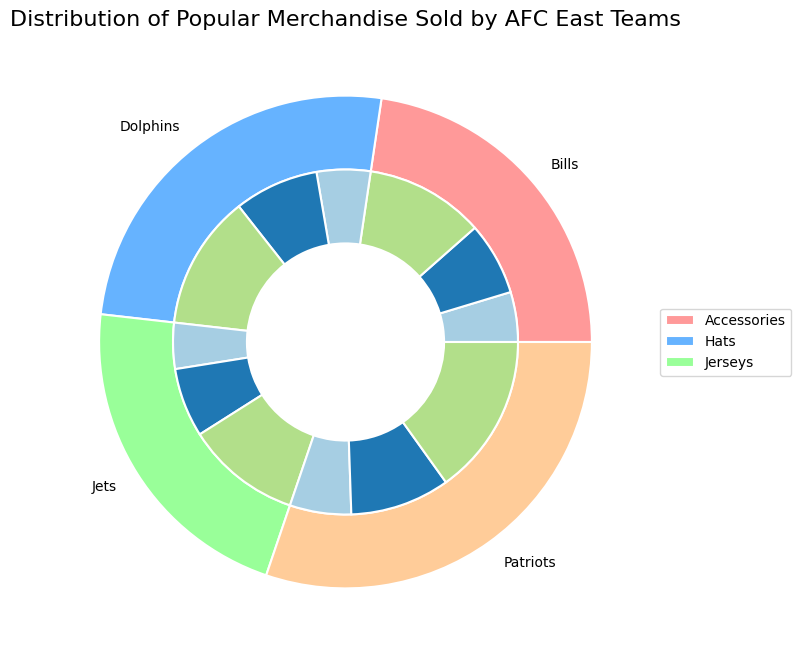Which team sold the most jerseys? The outer ring of the chart represents jersey sales for each team. By observing the size of the sections, the Patriots' section is the largest, indicating they sold the most jerseys.
Answer: Patriots How do the accessory sales of the Jets compare to the Bills? Comparing the inner rings corresponding to accessories for the Jets and Bills shows that the sections are almost the same size, but the Jets' section is slightly larger. Therefore, the Jets sold more accessories than the Bills.
Answer: Jets What is the total number of hats sold by all teams combined? The total number of hats sold is the sum of hat sales for each team: 2200 (Dolphins) + 1800 (Jets) + 2600 (Patriots) + 1900 (Bills) = 8500.
Answer: 8500 Which merchandise item did the Dolphins sell least? For the Dolphins, Accessories occupy the smallest section in the inner ring, indicating it is the least sold item.
Answer: Accessories By how much do Patriots' hats sales exceed Jets' hats sales? Subtract the number of hats sold by the Jets from those sold by the Patriots: 2600 (Patriots) - 1800 (Jets) = 800.
Answer: 800 Which team sold the least number of jerseys? The smallest section in the outer ring representing jersey sales is the Jets, indicating they sold the least jerseys.
Answer: Jets How does the number of accessories sold by the Dolphins compare to the total number sold by the Jets and Patriots? The Dolphins sold 1400 accessories. The Jets and Patriots combined sold 1200 (Jets) + 1600 (Patriots) = 2800 accessories. The Dolphins sold less than half as many accessories as the combined total of the Jets and Patriots.
Answer: Less than half Rank the teams in order of total merchandise sales from highest to lowest. Summing up the quantities for each team: Dolphins (3500+2200+1400=7100), Jets (3000+1800+1200=6000), Patriots (4200+2600+1600=8400), Bills (3100+1900+1300=6300). The order is: Patriots, Dolphins, Bills, Jets.
Answer: Patriots, Dolphins, Bills, Jets What percentage of the total jerseys sold were by the Bills? The total jerseys sold by all teams are 3500+3000+4200+3100=13800. Bills sold 3100 jerseys. The percentage is (3100/13800)*100 ≈ 22.46%.
Answer: 22.46% Are the hat sales of the Dolphins closer to those of the Patriots or the Bills? Dolphins sold 2200 hats, Patriots sold 2600, and Bills sold 1900. The difference between Dolphins and Patriots is 2600-2200=400, while the difference between Dolphins and Bills is 2200-1900=300. The Dolphins' hat sales are closer to those of the Bills.
Answer: Bills 